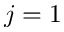<formula> <loc_0><loc_0><loc_500><loc_500>j = 1</formula> 